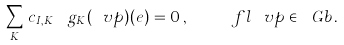<formula> <loc_0><loc_0><loc_500><loc_500>\sum _ { K } \, c _ { I , K } \, \ g _ { K } ( \ v p ) ( e ) \, = 0 \, , \quad \ f l \, \ v p \in { \ G b } \, .</formula> 